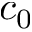<formula> <loc_0><loc_0><loc_500><loc_500>c _ { 0 }</formula> 